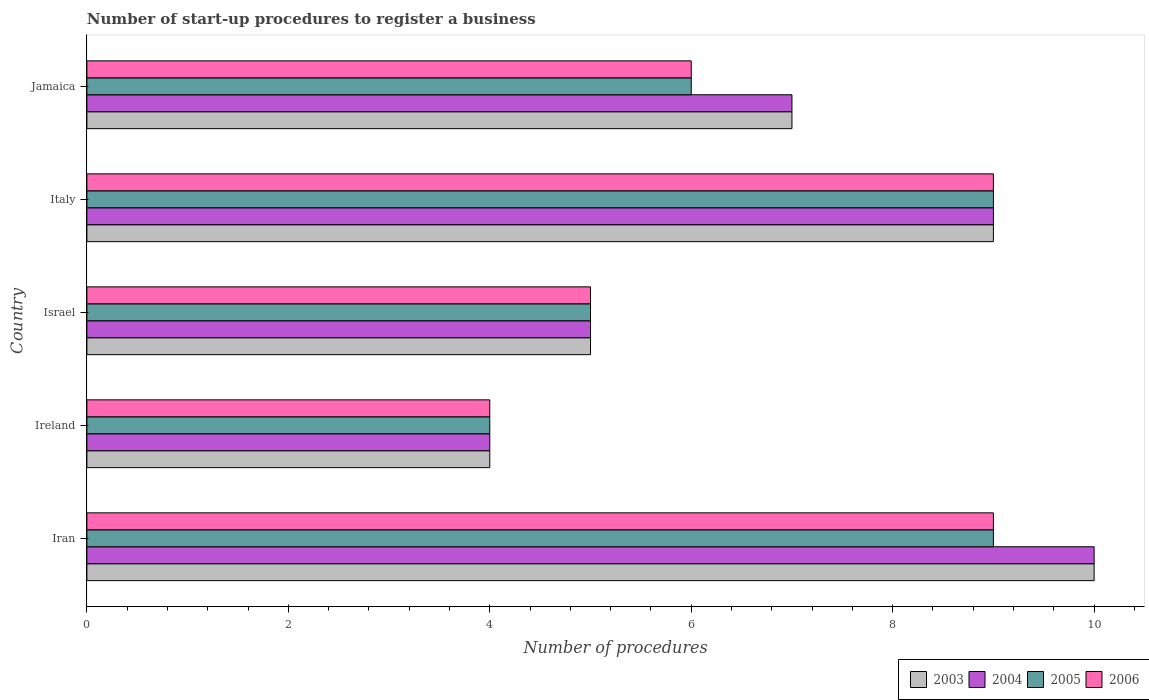How many groups of bars are there?
Offer a very short reply. 5. Are the number of bars per tick equal to the number of legend labels?
Offer a terse response. Yes. Are the number of bars on each tick of the Y-axis equal?
Make the answer very short. Yes. How many bars are there on the 2nd tick from the top?
Your answer should be compact. 4. How many bars are there on the 3rd tick from the bottom?
Keep it short and to the point. 4. What is the label of the 1st group of bars from the top?
Provide a succinct answer. Jamaica. Across all countries, what is the maximum number of procedures required to register a business in 2005?
Provide a short and direct response. 9. In which country was the number of procedures required to register a business in 2003 maximum?
Offer a very short reply. Iran. In which country was the number of procedures required to register a business in 2004 minimum?
Provide a succinct answer. Ireland. What is the difference between the number of procedures required to register a business in 2006 in Italy and the number of procedures required to register a business in 2004 in Iran?
Make the answer very short. -1. What is the average number of procedures required to register a business in 2006 per country?
Make the answer very short. 6.6. What is the difference between the number of procedures required to register a business in 2003 and number of procedures required to register a business in 2006 in Ireland?
Your response must be concise. 0. In how many countries, is the number of procedures required to register a business in 2005 greater than 7.6 ?
Ensure brevity in your answer.  2. What is the ratio of the number of procedures required to register a business in 2004 in Italy to that in Jamaica?
Your answer should be compact. 1.29. Is the difference between the number of procedures required to register a business in 2003 in Iran and Ireland greater than the difference between the number of procedures required to register a business in 2006 in Iran and Ireland?
Offer a very short reply. Yes. What is the difference between the highest and the second highest number of procedures required to register a business in 2006?
Ensure brevity in your answer.  0. What is the difference between the highest and the lowest number of procedures required to register a business in 2004?
Your answer should be compact. 6. In how many countries, is the number of procedures required to register a business in 2005 greater than the average number of procedures required to register a business in 2005 taken over all countries?
Make the answer very short. 2. Is the sum of the number of procedures required to register a business in 2004 in Italy and Jamaica greater than the maximum number of procedures required to register a business in 2006 across all countries?
Give a very brief answer. Yes. How many countries are there in the graph?
Ensure brevity in your answer.  5. Are the values on the major ticks of X-axis written in scientific E-notation?
Ensure brevity in your answer.  No. Does the graph contain any zero values?
Offer a terse response. No. Does the graph contain grids?
Offer a terse response. No. How are the legend labels stacked?
Your answer should be compact. Horizontal. What is the title of the graph?
Provide a short and direct response. Number of start-up procedures to register a business. Does "1972" appear as one of the legend labels in the graph?
Offer a very short reply. No. What is the label or title of the X-axis?
Provide a succinct answer. Number of procedures. What is the label or title of the Y-axis?
Give a very brief answer. Country. What is the Number of procedures in 2003 in Iran?
Ensure brevity in your answer.  10. What is the Number of procedures of 2004 in Iran?
Offer a very short reply. 10. What is the Number of procedures of 2005 in Iran?
Your answer should be compact. 9. What is the Number of procedures of 2003 in Ireland?
Ensure brevity in your answer.  4. What is the Number of procedures of 2004 in Ireland?
Keep it short and to the point. 4. What is the Number of procedures in 2005 in Ireland?
Your answer should be compact. 4. What is the Number of procedures in 2003 in Israel?
Provide a short and direct response. 5. What is the Number of procedures of 2006 in Israel?
Your response must be concise. 5. What is the Number of procedures of 2004 in Italy?
Give a very brief answer. 9. What is the Number of procedures of 2006 in Italy?
Your answer should be very brief. 9. What is the Number of procedures of 2003 in Jamaica?
Give a very brief answer. 7. What is the Number of procedures of 2004 in Jamaica?
Offer a very short reply. 7. What is the Number of procedures in 2006 in Jamaica?
Make the answer very short. 6. Across all countries, what is the maximum Number of procedures in 2003?
Offer a very short reply. 10. Across all countries, what is the maximum Number of procedures in 2005?
Keep it short and to the point. 9. Across all countries, what is the minimum Number of procedures in 2003?
Provide a succinct answer. 4. Across all countries, what is the minimum Number of procedures of 2004?
Provide a short and direct response. 4. Across all countries, what is the minimum Number of procedures of 2006?
Ensure brevity in your answer.  4. What is the difference between the Number of procedures of 2005 in Iran and that in Ireland?
Offer a very short reply. 5. What is the difference between the Number of procedures of 2006 in Iran and that in Ireland?
Provide a short and direct response. 5. What is the difference between the Number of procedures of 2006 in Iran and that in Israel?
Ensure brevity in your answer.  4. What is the difference between the Number of procedures of 2004 in Iran and that in Italy?
Give a very brief answer. 1. What is the difference between the Number of procedures of 2006 in Iran and that in Italy?
Offer a terse response. 0. What is the difference between the Number of procedures of 2006 in Iran and that in Jamaica?
Your answer should be compact. 3. What is the difference between the Number of procedures in 2003 in Ireland and that in Israel?
Offer a terse response. -1. What is the difference between the Number of procedures in 2004 in Ireland and that in Israel?
Make the answer very short. -1. What is the difference between the Number of procedures of 2005 in Ireland and that in Israel?
Keep it short and to the point. -1. What is the difference between the Number of procedures of 2006 in Ireland and that in Israel?
Your answer should be very brief. -1. What is the difference between the Number of procedures in 2004 in Ireland and that in Italy?
Offer a very short reply. -5. What is the difference between the Number of procedures in 2004 in Ireland and that in Jamaica?
Offer a terse response. -3. What is the difference between the Number of procedures of 2006 in Ireland and that in Jamaica?
Provide a short and direct response. -2. What is the difference between the Number of procedures in 2006 in Israel and that in Italy?
Ensure brevity in your answer.  -4. What is the difference between the Number of procedures in 2003 in Israel and that in Jamaica?
Offer a terse response. -2. What is the difference between the Number of procedures in 2004 in Israel and that in Jamaica?
Offer a terse response. -2. What is the difference between the Number of procedures in 2005 in Israel and that in Jamaica?
Provide a succinct answer. -1. What is the difference between the Number of procedures in 2004 in Italy and that in Jamaica?
Give a very brief answer. 2. What is the difference between the Number of procedures of 2005 in Italy and that in Jamaica?
Offer a very short reply. 3. What is the difference between the Number of procedures in 2004 in Iran and the Number of procedures in 2005 in Ireland?
Offer a terse response. 6. What is the difference between the Number of procedures of 2004 in Iran and the Number of procedures of 2006 in Ireland?
Keep it short and to the point. 6. What is the difference between the Number of procedures in 2005 in Iran and the Number of procedures in 2006 in Ireland?
Ensure brevity in your answer.  5. What is the difference between the Number of procedures in 2003 in Iran and the Number of procedures in 2004 in Israel?
Your response must be concise. 5. What is the difference between the Number of procedures of 2003 in Iran and the Number of procedures of 2005 in Israel?
Your answer should be very brief. 5. What is the difference between the Number of procedures in 2003 in Iran and the Number of procedures in 2006 in Israel?
Keep it short and to the point. 5. What is the difference between the Number of procedures of 2005 in Iran and the Number of procedures of 2006 in Israel?
Make the answer very short. 4. What is the difference between the Number of procedures in 2003 in Iran and the Number of procedures in 2004 in Italy?
Offer a very short reply. 1. What is the difference between the Number of procedures in 2004 in Iran and the Number of procedures in 2005 in Italy?
Make the answer very short. 1. What is the difference between the Number of procedures of 2005 in Iran and the Number of procedures of 2006 in Italy?
Make the answer very short. 0. What is the difference between the Number of procedures of 2003 in Iran and the Number of procedures of 2006 in Jamaica?
Your response must be concise. 4. What is the difference between the Number of procedures in 2003 in Ireland and the Number of procedures in 2004 in Israel?
Your response must be concise. -1. What is the difference between the Number of procedures in 2003 in Ireland and the Number of procedures in 2005 in Israel?
Offer a very short reply. -1. What is the difference between the Number of procedures in 2003 in Ireland and the Number of procedures in 2006 in Israel?
Ensure brevity in your answer.  -1. What is the difference between the Number of procedures of 2003 in Ireland and the Number of procedures of 2006 in Italy?
Make the answer very short. -5. What is the difference between the Number of procedures of 2004 in Ireland and the Number of procedures of 2005 in Italy?
Keep it short and to the point. -5. What is the difference between the Number of procedures in 2003 in Ireland and the Number of procedures in 2004 in Jamaica?
Make the answer very short. -3. What is the difference between the Number of procedures of 2004 in Ireland and the Number of procedures of 2005 in Jamaica?
Keep it short and to the point. -2. What is the difference between the Number of procedures of 2005 in Ireland and the Number of procedures of 2006 in Jamaica?
Your answer should be very brief. -2. What is the difference between the Number of procedures in 2003 in Israel and the Number of procedures in 2004 in Italy?
Make the answer very short. -4. What is the difference between the Number of procedures of 2004 in Israel and the Number of procedures of 2005 in Italy?
Provide a short and direct response. -4. What is the difference between the Number of procedures in 2004 in Israel and the Number of procedures in 2006 in Italy?
Make the answer very short. -4. What is the difference between the Number of procedures of 2005 in Israel and the Number of procedures of 2006 in Italy?
Offer a terse response. -4. What is the difference between the Number of procedures in 2003 in Israel and the Number of procedures in 2004 in Jamaica?
Your response must be concise. -2. What is the difference between the Number of procedures of 2004 in Israel and the Number of procedures of 2005 in Jamaica?
Provide a short and direct response. -1. What is the difference between the Number of procedures of 2005 in Israel and the Number of procedures of 2006 in Jamaica?
Provide a short and direct response. -1. What is the difference between the Number of procedures in 2003 in Italy and the Number of procedures in 2006 in Jamaica?
Your answer should be compact. 3. What is the difference between the Number of procedures of 2004 in Italy and the Number of procedures of 2006 in Jamaica?
Provide a short and direct response. 3. What is the difference between the Number of procedures in 2005 in Italy and the Number of procedures in 2006 in Jamaica?
Offer a very short reply. 3. What is the average Number of procedures of 2003 per country?
Your response must be concise. 7. What is the average Number of procedures of 2006 per country?
Your answer should be compact. 6.6. What is the difference between the Number of procedures of 2003 and Number of procedures of 2005 in Iran?
Your answer should be compact. 1. What is the difference between the Number of procedures of 2003 and Number of procedures of 2006 in Iran?
Give a very brief answer. 1. What is the difference between the Number of procedures of 2003 and Number of procedures of 2005 in Ireland?
Provide a short and direct response. 0. What is the difference between the Number of procedures of 2004 and Number of procedures of 2005 in Ireland?
Your answer should be compact. 0. What is the difference between the Number of procedures of 2004 and Number of procedures of 2006 in Ireland?
Offer a very short reply. 0. What is the difference between the Number of procedures of 2003 and Number of procedures of 2004 in Israel?
Provide a succinct answer. 0. What is the difference between the Number of procedures of 2003 and Number of procedures of 2006 in Israel?
Keep it short and to the point. 0. What is the difference between the Number of procedures in 2004 and Number of procedures in 2005 in Israel?
Provide a succinct answer. 0. What is the difference between the Number of procedures of 2005 and Number of procedures of 2006 in Israel?
Ensure brevity in your answer.  0. What is the difference between the Number of procedures of 2003 and Number of procedures of 2004 in Italy?
Your answer should be very brief. 0. What is the difference between the Number of procedures of 2003 and Number of procedures of 2006 in Italy?
Your response must be concise. 0. What is the difference between the Number of procedures in 2005 and Number of procedures in 2006 in Italy?
Make the answer very short. 0. What is the difference between the Number of procedures in 2003 and Number of procedures in 2006 in Jamaica?
Provide a short and direct response. 1. What is the difference between the Number of procedures of 2005 and Number of procedures of 2006 in Jamaica?
Give a very brief answer. 0. What is the ratio of the Number of procedures in 2004 in Iran to that in Ireland?
Ensure brevity in your answer.  2.5. What is the ratio of the Number of procedures of 2005 in Iran to that in Ireland?
Your answer should be very brief. 2.25. What is the ratio of the Number of procedures in 2006 in Iran to that in Ireland?
Make the answer very short. 2.25. What is the ratio of the Number of procedures of 2005 in Iran to that in Israel?
Provide a succinct answer. 1.8. What is the ratio of the Number of procedures in 2004 in Iran to that in Italy?
Make the answer very short. 1.11. What is the ratio of the Number of procedures of 2003 in Iran to that in Jamaica?
Your answer should be very brief. 1.43. What is the ratio of the Number of procedures of 2004 in Iran to that in Jamaica?
Give a very brief answer. 1.43. What is the ratio of the Number of procedures in 2004 in Ireland to that in Israel?
Keep it short and to the point. 0.8. What is the ratio of the Number of procedures in 2005 in Ireland to that in Israel?
Offer a very short reply. 0.8. What is the ratio of the Number of procedures in 2006 in Ireland to that in Israel?
Your answer should be compact. 0.8. What is the ratio of the Number of procedures in 2003 in Ireland to that in Italy?
Your answer should be compact. 0.44. What is the ratio of the Number of procedures in 2004 in Ireland to that in Italy?
Provide a short and direct response. 0.44. What is the ratio of the Number of procedures of 2005 in Ireland to that in Italy?
Ensure brevity in your answer.  0.44. What is the ratio of the Number of procedures in 2006 in Ireland to that in Italy?
Give a very brief answer. 0.44. What is the ratio of the Number of procedures in 2006 in Ireland to that in Jamaica?
Make the answer very short. 0.67. What is the ratio of the Number of procedures in 2003 in Israel to that in Italy?
Your answer should be compact. 0.56. What is the ratio of the Number of procedures in 2004 in Israel to that in Italy?
Make the answer very short. 0.56. What is the ratio of the Number of procedures in 2005 in Israel to that in Italy?
Ensure brevity in your answer.  0.56. What is the ratio of the Number of procedures in 2006 in Israel to that in Italy?
Provide a succinct answer. 0.56. What is the ratio of the Number of procedures of 2003 in Israel to that in Jamaica?
Keep it short and to the point. 0.71. What is the ratio of the Number of procedures in 2004 in Israel to that in Jamaica?
Provide a succinct answer. 0.71. What is the ratio of the Number of procedures of 2003 in Italy to that in Jamaica?
Provide a succinct answer. 1.29. What is the ratio of the Number of procedures of 2004 in Italy to that in Jamaica?
Keep it short and to the point. 1.29. What is the ratio of the Number of procedures in 2006 in Italy to that in Jamaica?
Provide a succinct answer. 1.5. What is the difference between the highest and the second highest Number of procedures of 2003?
Your response must be concise. 1. 